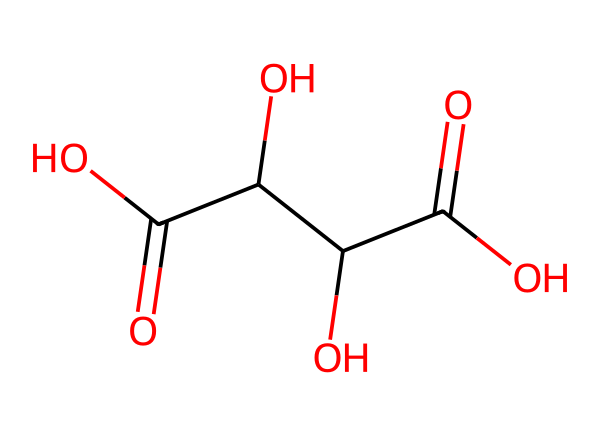What is the name of this chemical? The SMILES representation denotes tartaric acid, which is a well-known organic acid commonly found in grapes and used in wine production.
Answer: tartaric acid How many carbon atoms are present in this molecule? Analyzing the SMILES structure, we can count four carbon atoms labeled in the chain before reaching the carboxylic acid functionalities.
Answer: four What is the functional group that characterizes this molecule as an acid? The presence of the carboxylic acid group (-COOH) indicates that this molecule is an acid. In the structure, there are two such -COOH groups confirming this classification.
Answer: carboxylic acid What role does tartaric acid play in wine fermentation? Tartaric acid helps to stabilize the pH during fermentation, leading to a balance that is favorable for the yeast activity and enhances the wine quality overall.
Answer: pH stabilization How does tartaric acid influence grape ripening? Tartaric acid contributes to the development of flavor and acidity in grapes. Its concentration decreases as grapes ripen, affecting the overall taste of the wine produced from them.
Answer: flavor and acidity What is the total number of oxygen atoms in this molecule? In the SMILES representation, we can visually count six oxygen atoms present in the carboxylic groups and hydroxyl groups attached to the carbon skeleton.
Answer: six How does the presence of tartaric acid impact the taste of wine? Tartaric acid adds tartness to the wine's flavor profile, and its balance plays a crucial role in the overall sensory experience of the wine.
Answer: tartness 